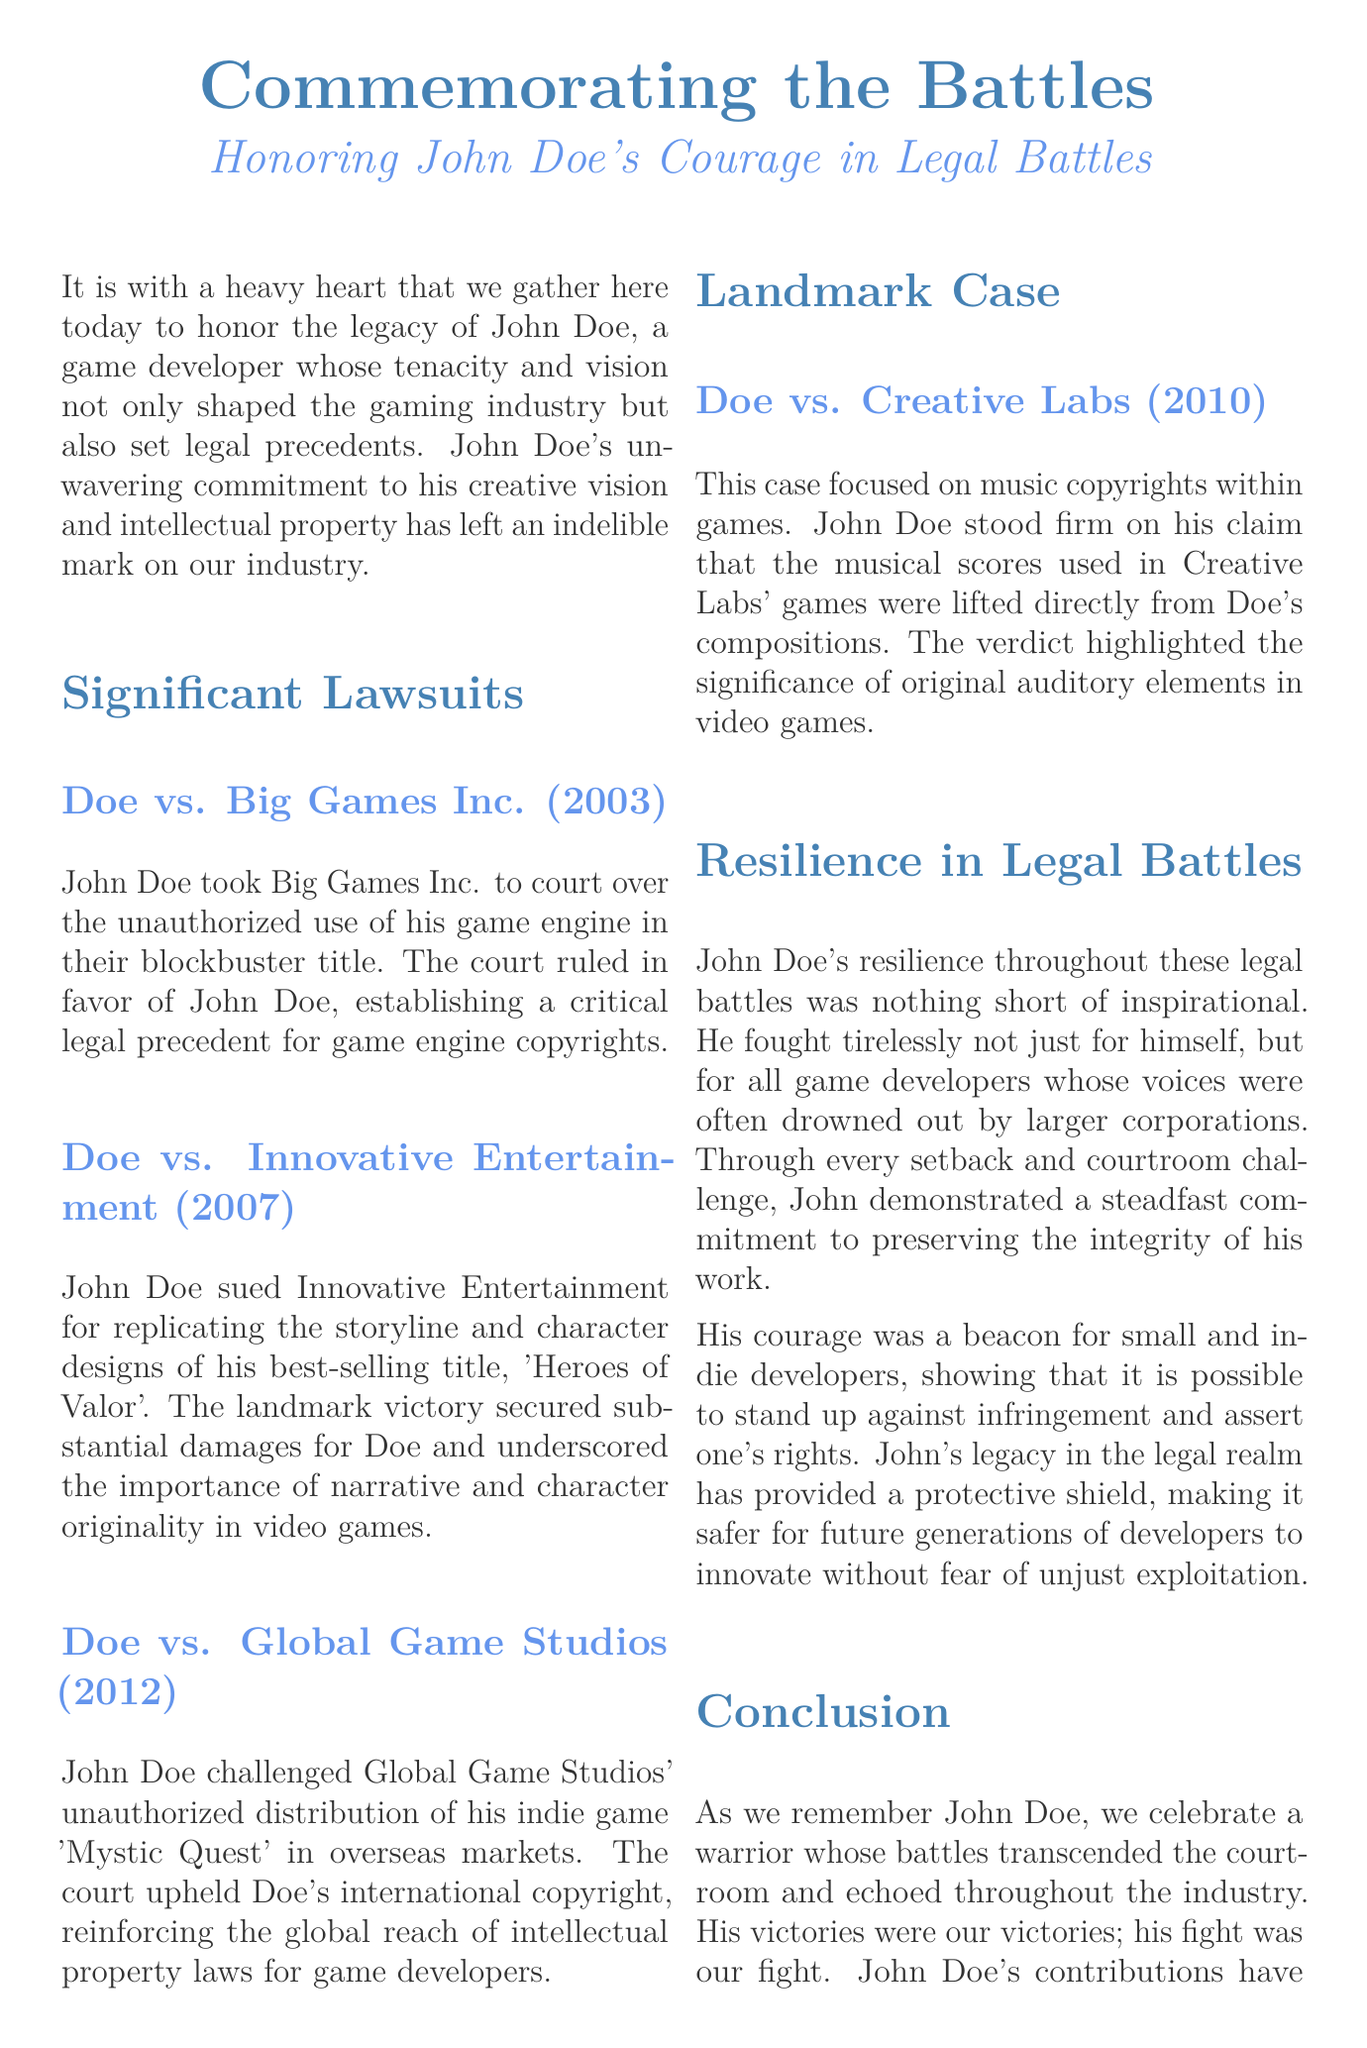What is the title of the document? The title of the document is presented prominently at the beginning.
Answer: Commemorating the Battles Who is the eulogy honoring? The eulogy focuses on the achievements and legacy of a specific individual mentioned.
Answer: John Doe In what year was the lawsuit against Big Games Inc. filed? The year of the lawsuit against Big Games Inc. is listed in the "Significant Lawsuits" section.
Answer: 2003 What was the key issue in the Doe vs. Innovative Entertainment case? The issue in this case pertains to specific elements from John's creation that were copied.
Answer: Storyline and character designs What landmark legal victory is discussed in the section about Creative Labs? The legal matter discussed revolves around a specific form of intellectual property.
Answer: Music copyrights How did John Doe's legal actions impact indie developers? The eulogy mentions the broader implications of John's battles for a specific group.
Answer: It inspired them What years are listed in connection with John Doe's significant lawsuits? The document provides a timeline of cases in the "Significant Lawsuits" section.
Answer: 2003, 2007, 2012 What is described as a protective measure for future developers? The document highlights an overarching theme about John's impact on rights within the industry.
Answer: His legacy What is the overall tone of the eulogy? The tone is inferred through the language used to describe John Doe's contributions and challenges faced.
Answer: Inspirational 